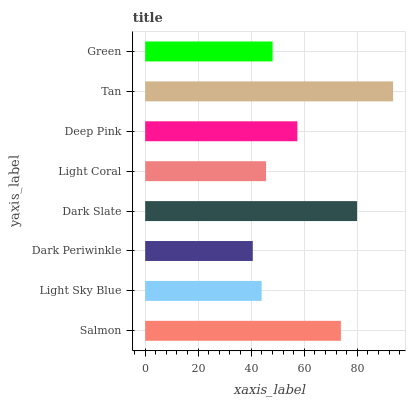Is Dark Periwinkle the minimum?
Answer yes or no. Yes. Is Tan the maximum?
Answer yes or no. Yes. Is Light Sky Blue the minimum?
Answer yes or no. No. Is Light Sky Blue the maximum?
Answer yes or no. No. Is Salmon greater than Light Sky Blue?
Answer yes or no. Yes. Is Light Sky Blue less than Salmon?
Answer yes or no. Yes. Is Light Sky Blue greater than Salmon?
Answer yes or no. No. Is Salmon less than Light Sky Blue?
Answer yes or no. No. Is Deep Pink the high median?
Answer yes or no. Yes. Is Green the low median?
Answer yes or no. Yes. Is Green the high median?
Answer yes or no. No. Is Salmon the low median?
Answer yes or no. No. 